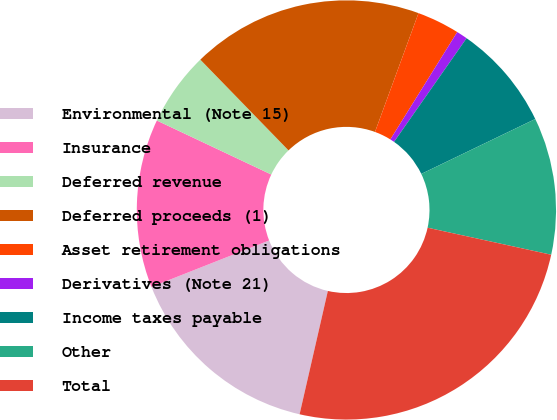Convert chart. <chart><loc_0><loc_0><loc_500><loc_500><pie_chart><fcel>Environmental (Note 15)<fcel>Insurance<fcel>Deferred revenue<fcel>Deferred proceeds (1)<fcel>Asset retirement obligations<fcel>Derivatives (Note 21)<fcel>Income taxes payable<fcel>Other<fcel>Total<nl><fcel>15.43%<fcel>13.0%<fcel>5.71%<fcel>17.86%<fcel>3.28%<fcel>0.85%<fcel>8.14%<fcel>10.57%<fcel>25.16%<nl></chart> 